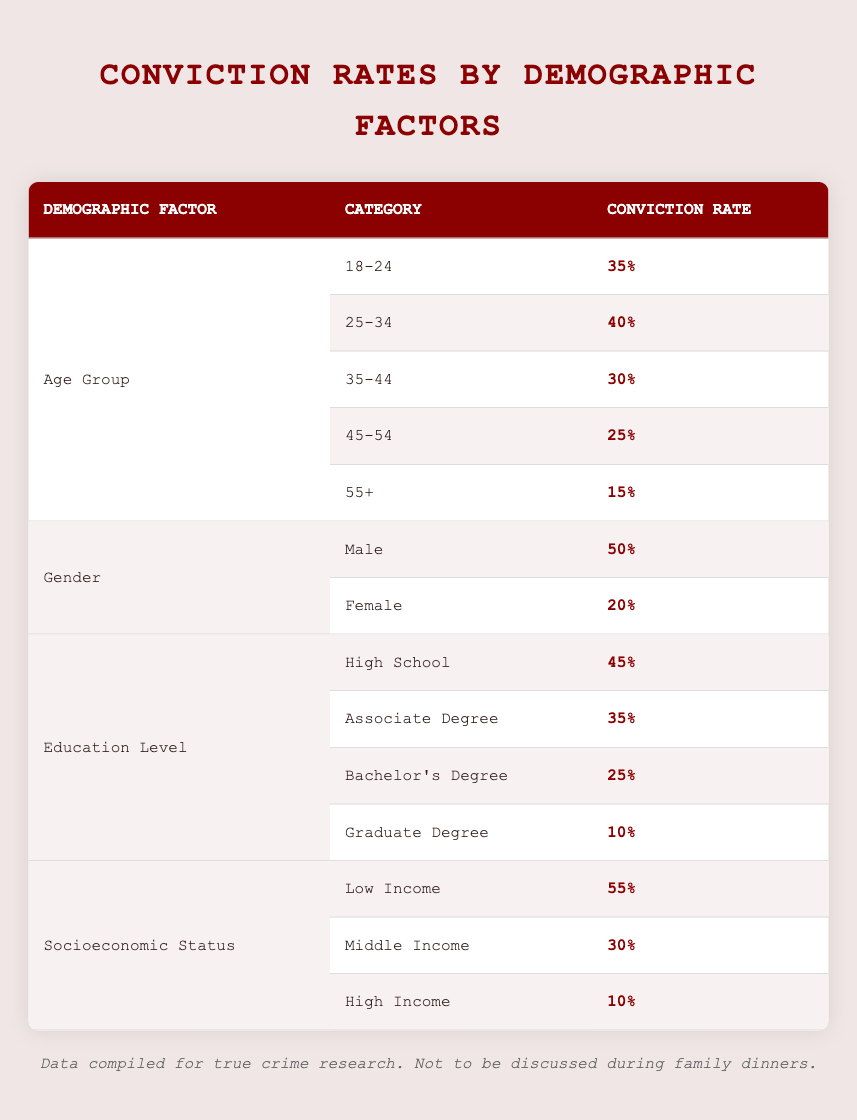What is the highest conviction rate for a specific age group? The age group "18-24" has the highest conviction rate at 35%, as it is listed first in the age group section of the table.
Answer: 35% What is the conviction rate for females? The table shows that the conviction rate for females is 20%.
Answer: 20% What is the average conviction rate for the low income and middle income categories? The conviction rate for low income is 55% and for middle income is 30%. Adding these gives 85%. Dividing by 2 gives an average of 42.5%.
Answer: 42.5% Is it true that the conviction rate decreases with increasing education level? Yes, the data shows that the conviction rate decreases as education level increases: High School (45%), Associate Degree (35%), Bachelor's Degree (25%), Graduate Degree (10%).
Answer: Yes What is the total conviction rate for all age groups combined? The total conviction rate is not directly provided, but can be found by adding the conviction rates of each age group: 35% + 40% + 30% + 25% + 15% = 145%. The total number of age group categories is 5, so the average is 145% / 5 = 29%.
Answer: 29% Which demographic factor has the highest conviction rate overall? The "Socioeconomic Status" category shows the highest conviction rate at 55% for "Low Income".
Answer: 55% What is the conviction rate for those aged 45-54 compared to those with a Graduate Degree? The conviction rate for the age group 45-54 is 25%, and for the Graduate Degree category, it is 10%. Thus, 25% is higher than 10%.
Answer: 25% is higher What is the difference in conviction rates between males and females? The conviction rate for males is 50% and for females is 20%. The difference is 50% - 20% = 30%.
Answer: 30% What is the necessary condition for an individual from the 55+ age group to be convicted? From the data, the conviction rate for the 55+ age group is 15%. Individuals in this category have a lower likelihood of conviction compared to younger groups.
Answer: Lower likelihood of conviction 